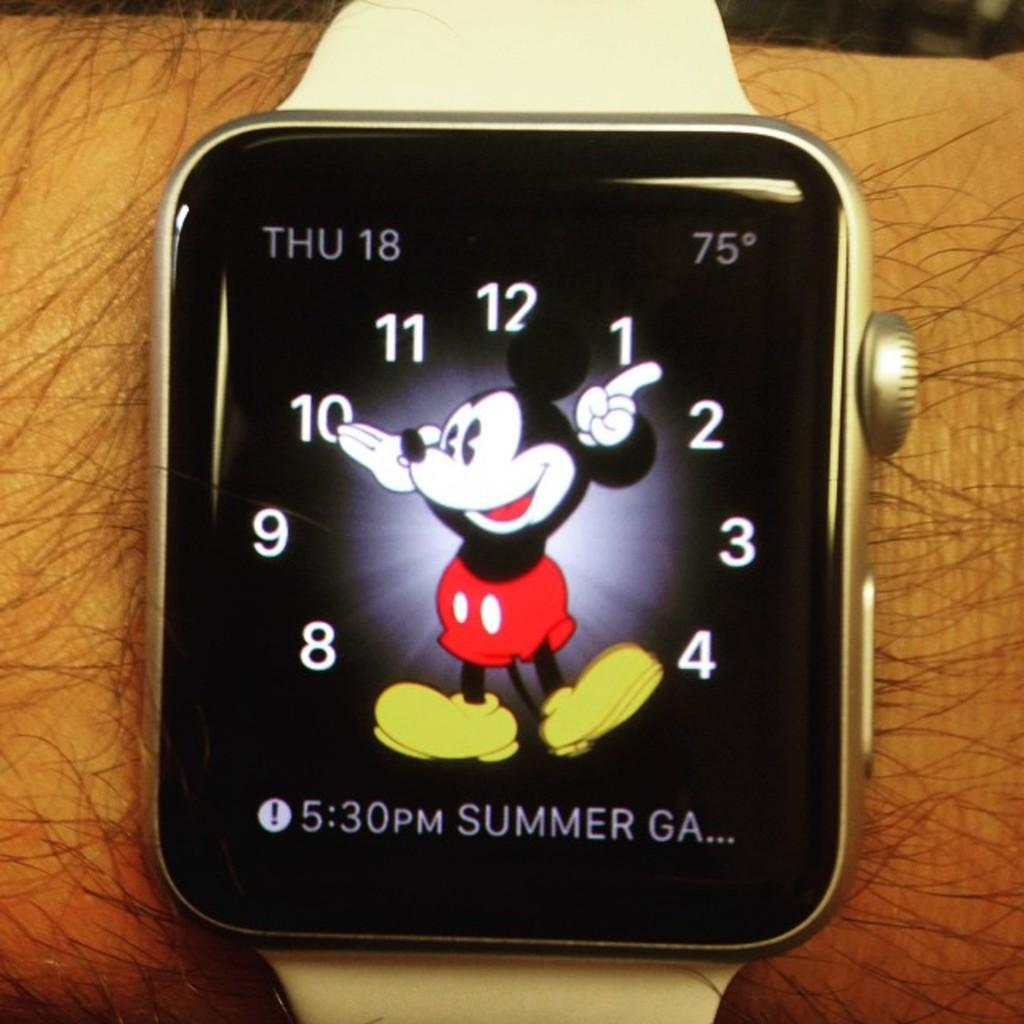<image>
Render a clear and concise summary of the photo. An Apple Watch shows that it's Thursday the 18th and 75 degrees outside. 